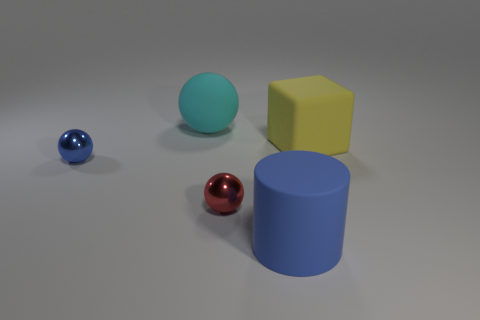Subtract all rubber spheres. How many spheres are left? 2 Add 1 yellow things. How many objects exist? 6 Subtract all green balls. Subtract all gray cylinders. How many balls are left? 3 Subtract all cylinders. How many objects are left? 4 Add 1 red metallic objects. How many red metallic objects are left? 2 Add 3 brown cylinders. How many brown cylinders exist? 3 Subtract 1 cyan spheres. How many objects are left? 4 Subtract all large gray matte balls. Subtract all large blue rubber cylinders. How many objects are left? 4 